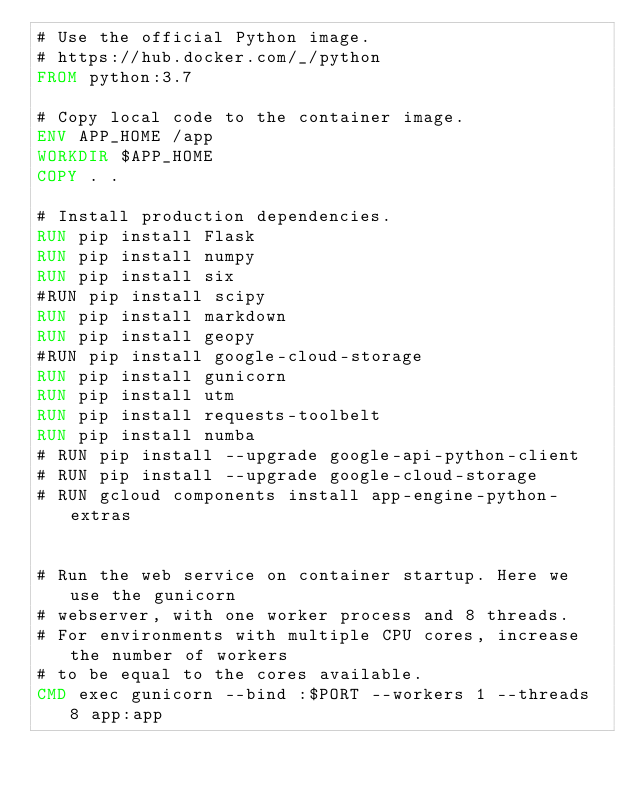Convert code to text. <code><loc_0><loc_0><loc_500><loc_500><_Dockerfile_># Use the official Python image.
# https://hub.docker.com/_/python
FROM python:3.7

# Copy local code to the container image.
ENV APP_HOME /app
WORKDIR $APP_HOME
COPY . .

# Install production dependencies.
RUN pip install Flask
RUN pip install numpy
RUN pip install six
#RUN pip install scipy
RUN pip install markdown
RUN pip install geopy
#RUN pip install google-cloud-storage
RUN pip install gunicorn
RUN pip install utm
RUN pip install requests-toolbelt
RUN pip install numba
# RUN pip install --upgrade google-api-python-client
# RUN pip install --upgrade google-cloud-storage
# RUN gcloud components install app-engine-python-extras


# Run the web service on container startup. Here we use the gunicorn
# webserver, with one worker process and 8 threads.
# For environments with multiple CPU cores, increase the number of workers
# to be equal to the cores available.
CMD exec gunicorn --bind :$PORT --workers 1 --threads 8 app:app</code> 